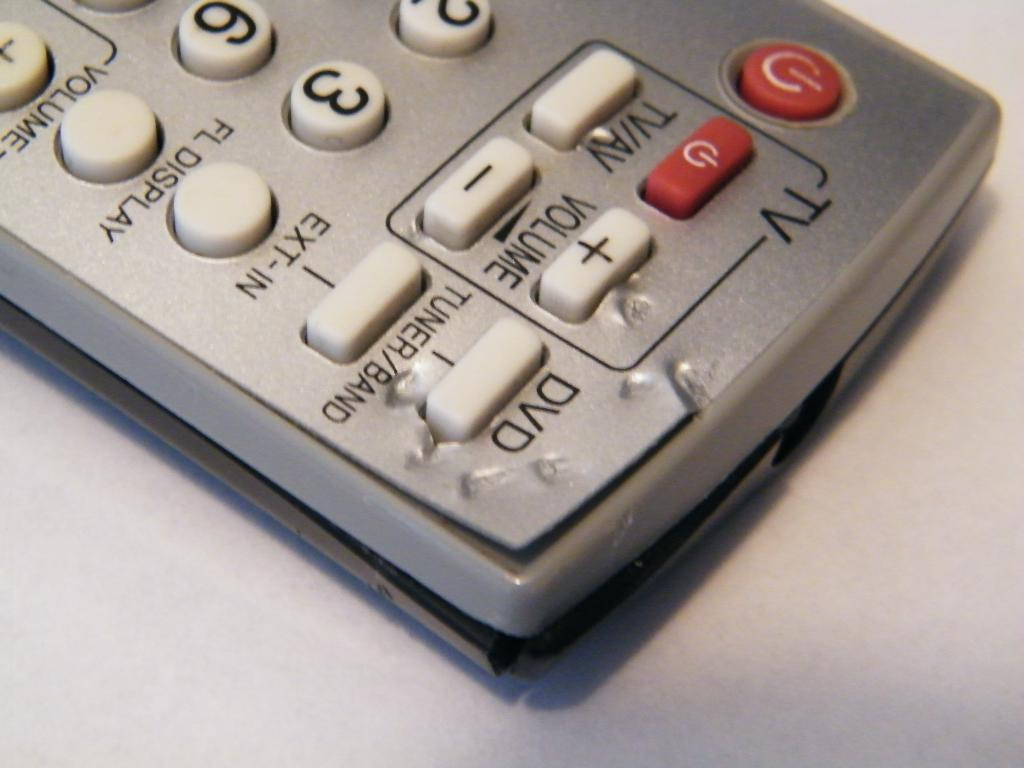<image>
Render a clear and concise summary of the photo. A television remote has been chewed by an animal right near the DVD and tuner/band buttons. 